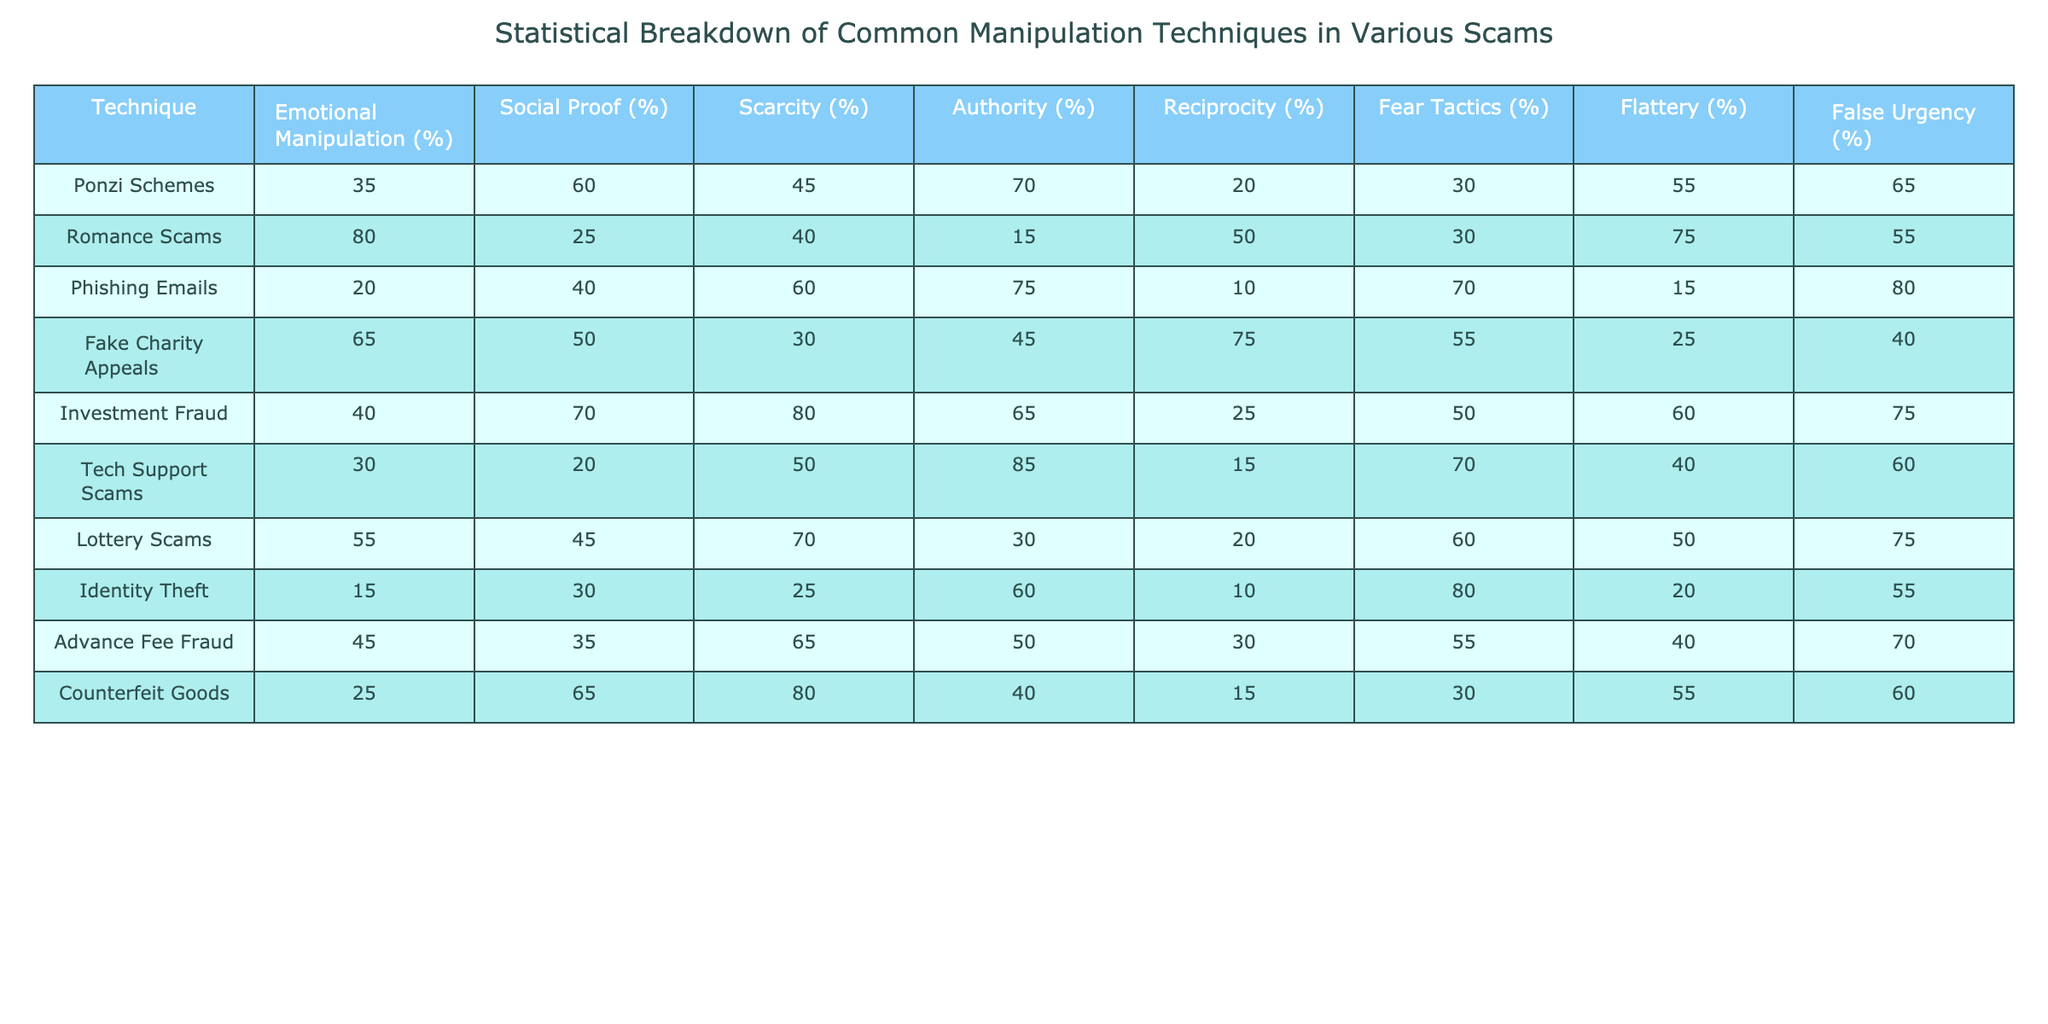What is the highest percentage of Emotional Manipulation used in any scam technique? Looking at the Emotional Manipulation column, the highest value is 80%, which is associated with Romance Scams.
Answer: 80% Which technique employs the highest percentage of Authority manipulation? By examining the Authority column, Tech Support Scams have the highest percentage at 85%.
Answer: 85% What is the sum of the Scarcity percentages for Ponzi Schemes and Fake Charity Appeals? The Scarcity percentage for Ponzi Schemes is 45%, and for Fake Charity Appeals, it is 30%. Adding these together gives: 45 + 30 = 75.
Answer: 75 Is it true that Identity Theft uses more Fear Tactics than Lottery Scams? Identity Theft has a Fear Tactics percentage of 80%, while Lottery Scams have a percentage of 60%. Therefore, it is true that Identity Theft uses more Fear Tactics.
Answer: Yes Which two techniques have the lowest percentage of Reciprocity? Looking at the Reciprocity column, both Phishing Emails and Identity Theft have the lowest percentage of 10% and 10%, respectively.
Answer: Phishing Emails and Identity Theft What is the average percentage of Social Proof across all techniques? We sum the Social Proof percentages: 60 + 25 + 40 + 50 + 70 + 20 + 45 + 30 + 35 + 65 = 600. There are 10 techniques, so the average is 600 / 10 = 60%.
Answer: 60% Which manipulation technique has the largest difference between its Emotional Manipulation and False Urgency percentages? For Ponzi Schemes, Emotional Manipulation is 35% and False Urgency is 65%, leading to a difference of 30%. For Romance Scams, it's 80% and 55%, a difference of 25%. The largest difference is for Ponzi Schemes.
Answer: Ponzi Schemes What percentage of Emotional Manipulation is used in Investment Fraud compared to Counterfeit Goods? Investment Fraud uses 40% Emotional Manipulation while Counterfeit Goods use 25%. The difference is 40 - 25 = 15%.
Answer: 15% How does the Flattery percentage of Fake Charity Appeals compare to that of Romance Scams? Fake Charity Appeals have a Flattery percentage of 25%, whereas Romance Scams have a percentage of 75%. Therefore, Romance Scams use more Flattery.
Answer: Romance Scams use more Flattery Which manipulation technique is most reliant on False Urgency? In the False Urgency column, Phishing Emails have the highest percentage at 80%, indicating they are most reliant on this manipulation technique.
Answer: Phishing Emails 